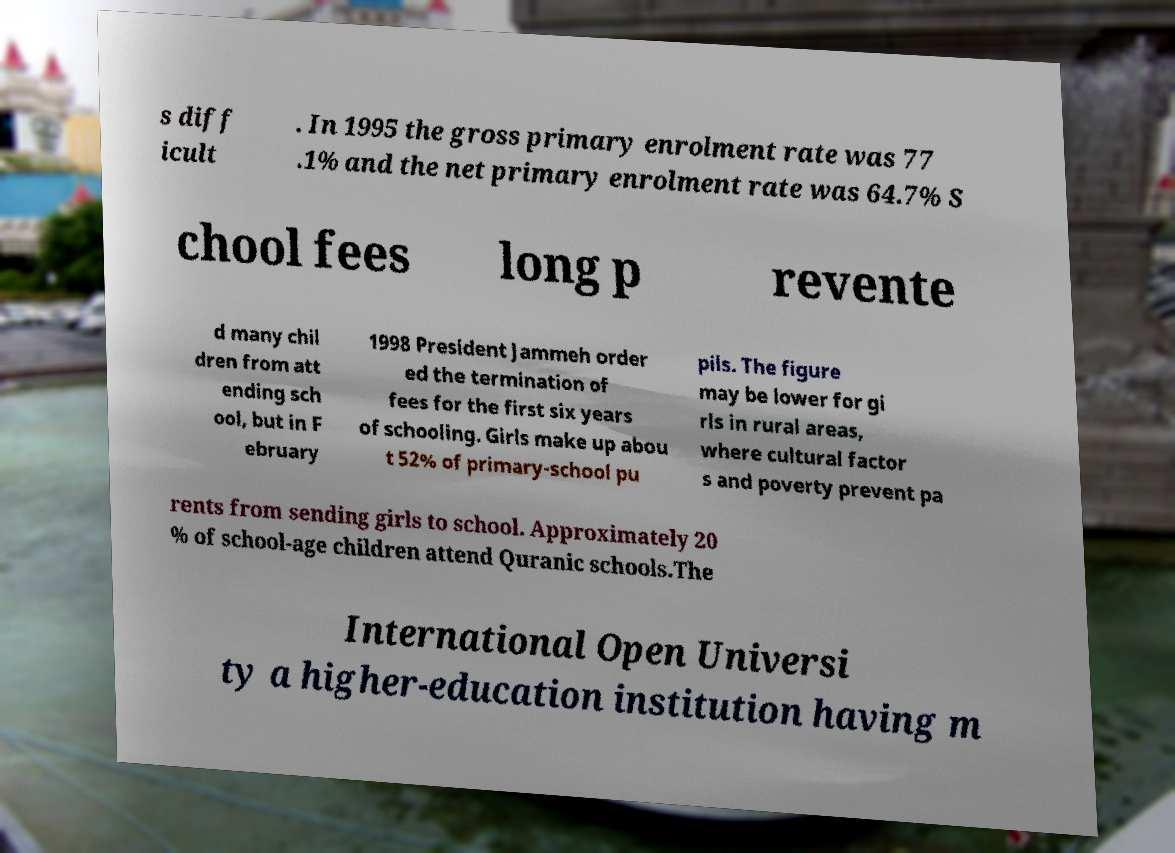There's text embedded in this image that I need extracted. Can you transcribe it verbatim? s diff icult . In 1995 the gross primary enrolment rate was 77 .1% and the net primary enrolment rate was 64.7% S chool fees long p revente d many chil dren from att ending sch ool, but in F ebruary 1998 President Jammeh order ed the termination of fees for the first six years of schooling. Girls make up abou t 52% of primary-school pu pils. The figure may be lower for gi rls in rural areas, where cultural factor s and poverty prevent pa rents from sending girls to school. Approximately 20 % of school-age children attend Quranic schools.The International Open Universi ty a higher-education institution having m 